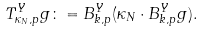<formula> <loc_0><loc_0><loc_500><loc_500>T _ { \kappa _ { N } , p } ^ { Y } g \colon = B _ { k , p } ^ { Y } ( \kappa _ { N } \cdot B _ { k , p } ^ { Y } g ) .</formula> 